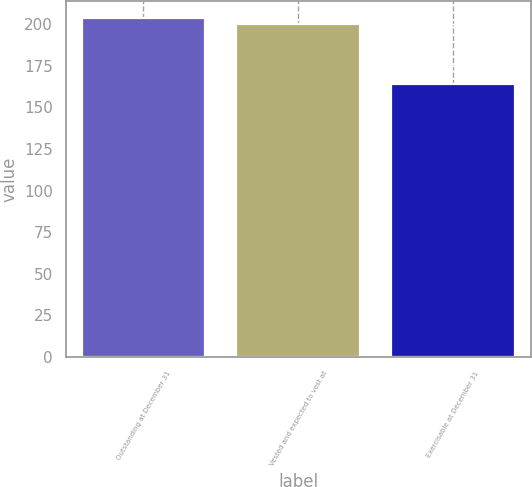Convert chart. <chart><loc_0><loc_0><loc_500><loc_500><bar_chart><fcel>Outstanding at December 31<fcel>Vested and expected to vest at<fcel>Exercisable at December 31<nl><fcel>203.7<fcel>200<fcel>164<nl></chart> 